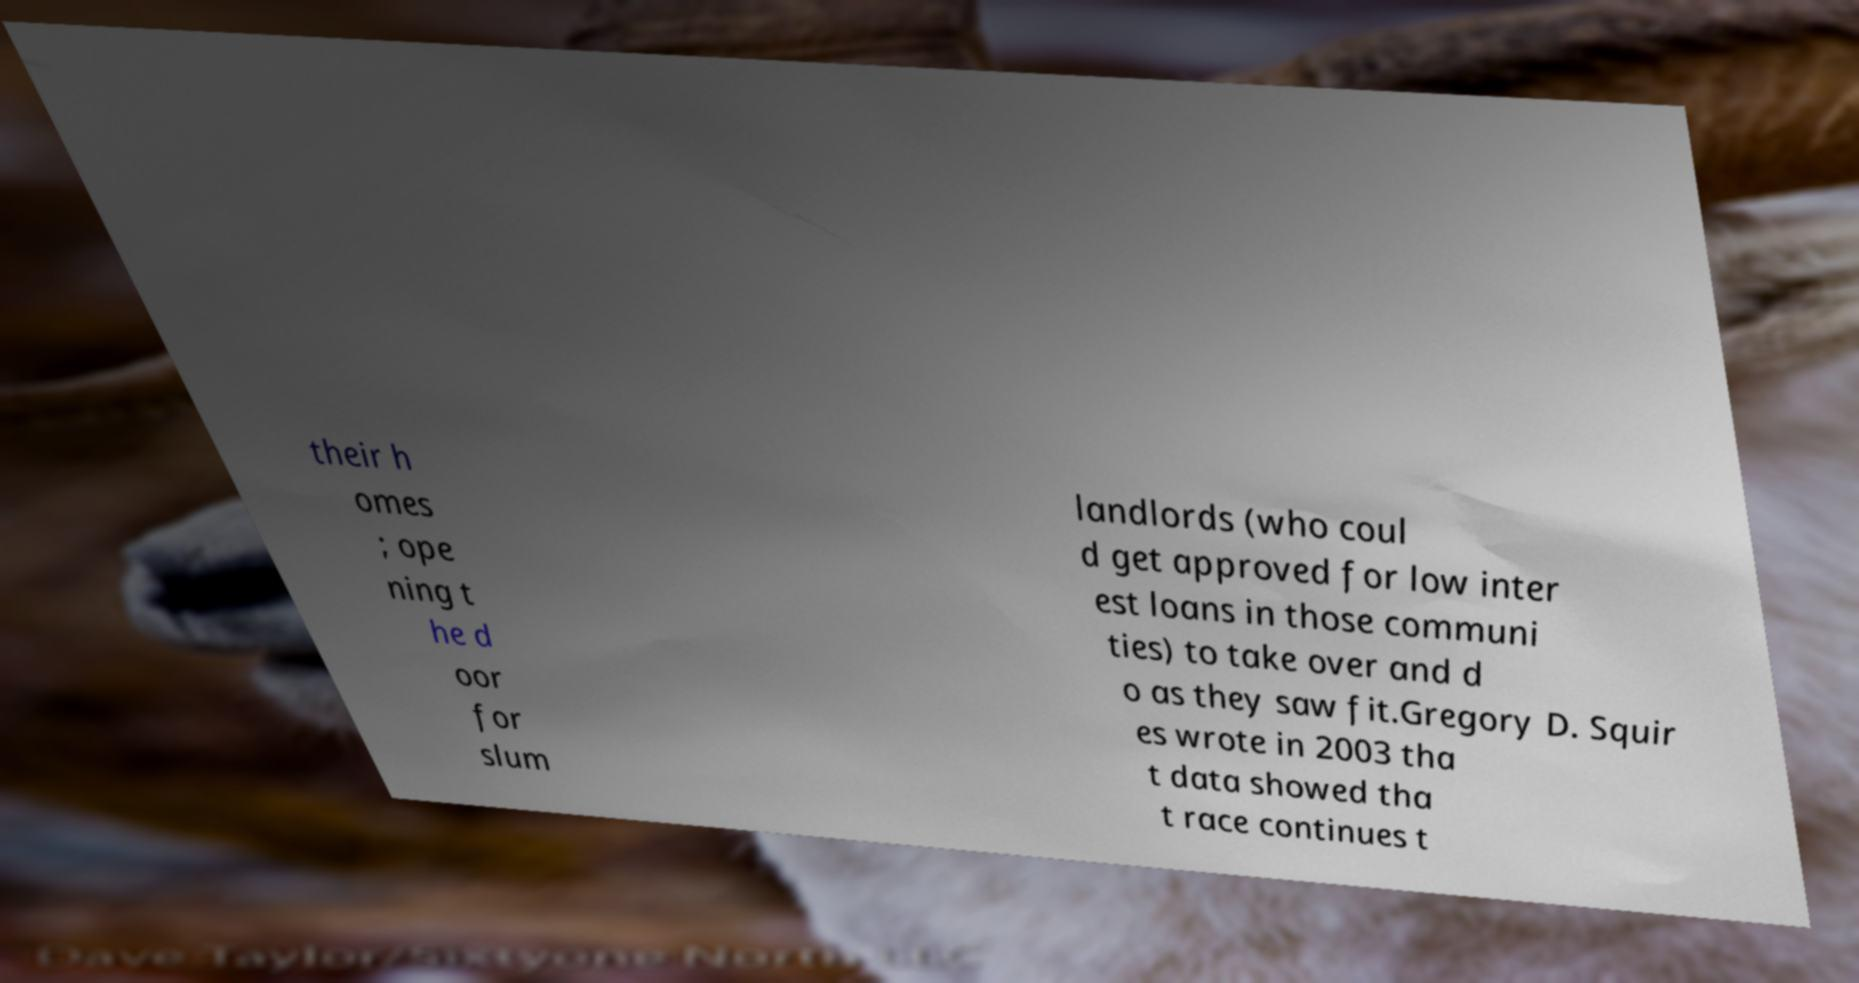Please identify and transcribe the text found in this image. their h omes ; ope ning t he d oor for slum landlords (who coul d get approved for low inter est loans in those communi ties) to take over and d o as they saw fit.Gregory D. Squir es wrote in 2003 tha t data showed tha t race continues t 